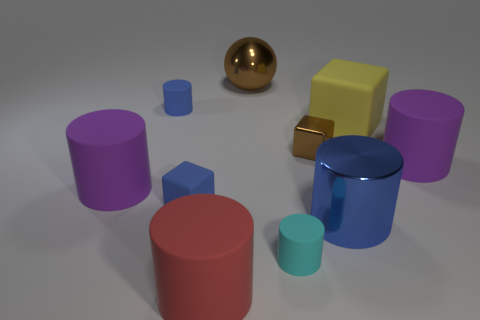Subtract all cyan cylinders. How many cylinders are left? 5 Subtract all blue cylinders. How many cylinders are left? 4 Subtract all balls. How many objects are left? 9 Add 10 blue shiny blocks. How many blue shiny blocks exist? 10 Subtract 0 gray cylinders. How many objects are left? 10 Subtract 1 balls. How many balls are left? 0 Subtract all cyan blocks. Subtract all brown cylinders. How many blocks are left? 3 Subtract all brown cubes. How many cyan cylinders are left? 1 Subtract all large blue objects. Subtract all tiny shiny things. How many objects are left? 8 Add 5 big purple things. How many big purple things are left? 7 